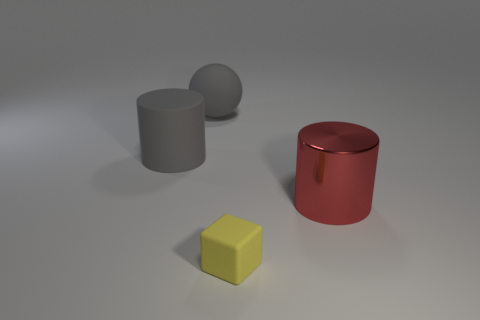Add 3 tiny objects. How many objects exist? 7 Subtract all green balls. Subtract all gray blocks. How many balls are left? 1 Subtract all green cylinders. How many yellow balls are left? 0 Subtract all yellow metal balls. Subtract all large gray rubber objects. How many objects are left? 2 Add 4 rubber things. How many rubber things are left? 7 Add 4 tiny rubber blocks. How many tiny rubber blocks exist? 5 Subtract 0 blue cubes. How many objects are left? 4 